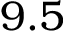Convert formula to latex. <formula><loc_0><loc_0><loc_500><loc_500>9 . 5</formula> 